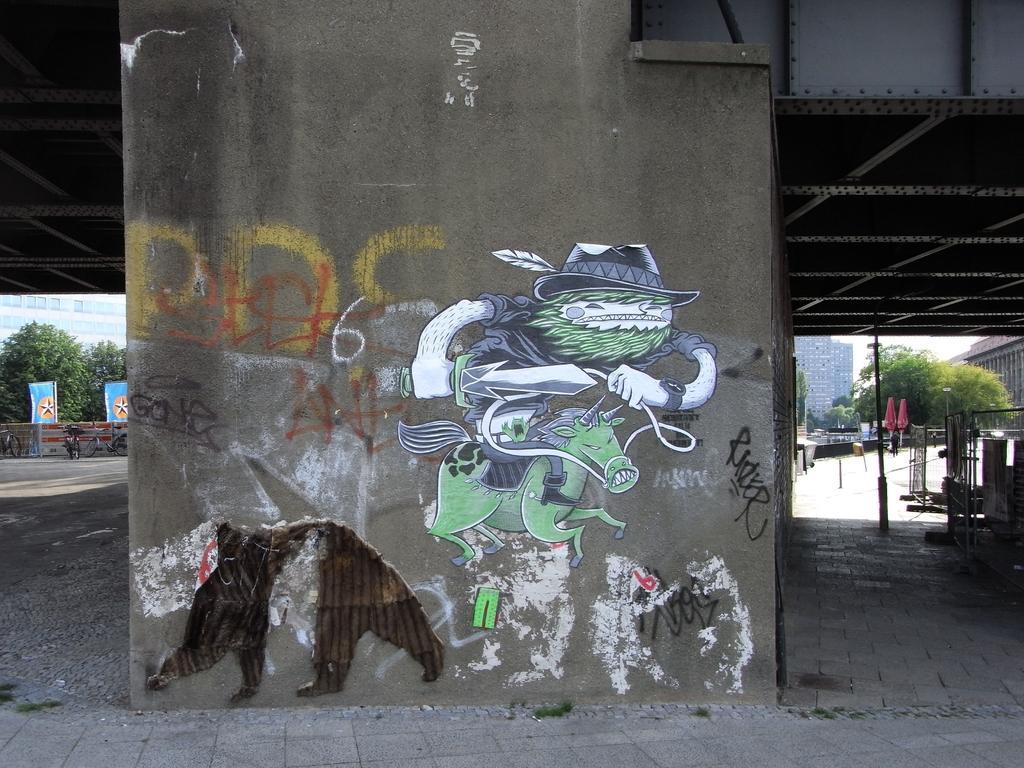How would you summarize this image in a sentence or two? It is a concrete wall there are paintings on it. On the right side there are green trees. 